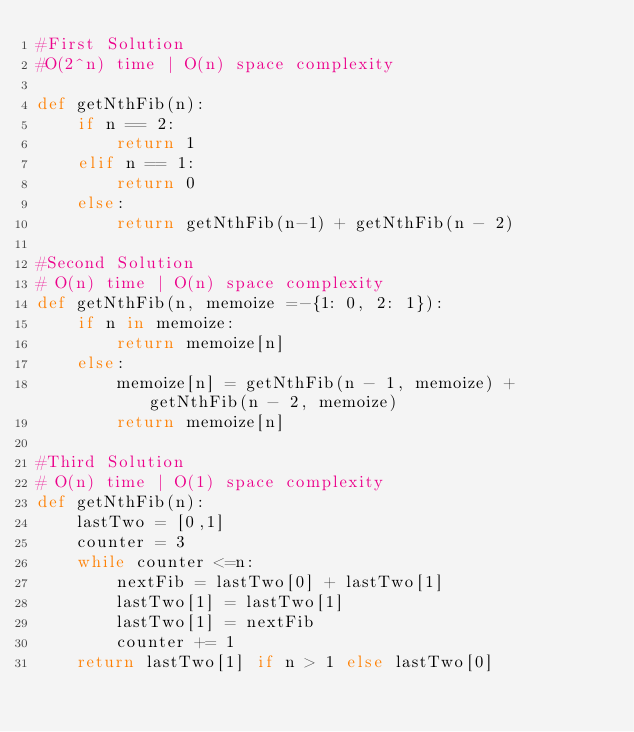<code> <loc_0><loc_0><loc_500><loc_500><_Python_>#First Solution
#O(2^n) time | O(n) space complexity

def getNthFib(n):
    if n == 2:
        return 1
    elif n == 1:
        return 0
    else:
        return getNthFib(n-1) + getNthFib(n - 2)

#Second Solution
# O(n) time | O(n) space complexity
def getNthFib(n, memoize =-{1: 0, 2: 1}):
    if n in memoize:
        return memoize[n]
    else:
        memoize[n] = getNthFib(n - 1, memoize) + getNthFib(n - 2, memoize)
        return memoize[n]

#Third Solution
# O(n) time | O(1) space complexity
def getNthFib(n):
    lastTwo = [0,1]
    counter = 3
    while counter <=n:
        nextFib = lastTwo[0] + lastTwo[1]
        lastTwo[1] = lastTwo[1]
        lastTwo[1] = nextFib
        counter += 1
    return lastTwo[1] if n > 1 else lastTwo[0]
</code> 